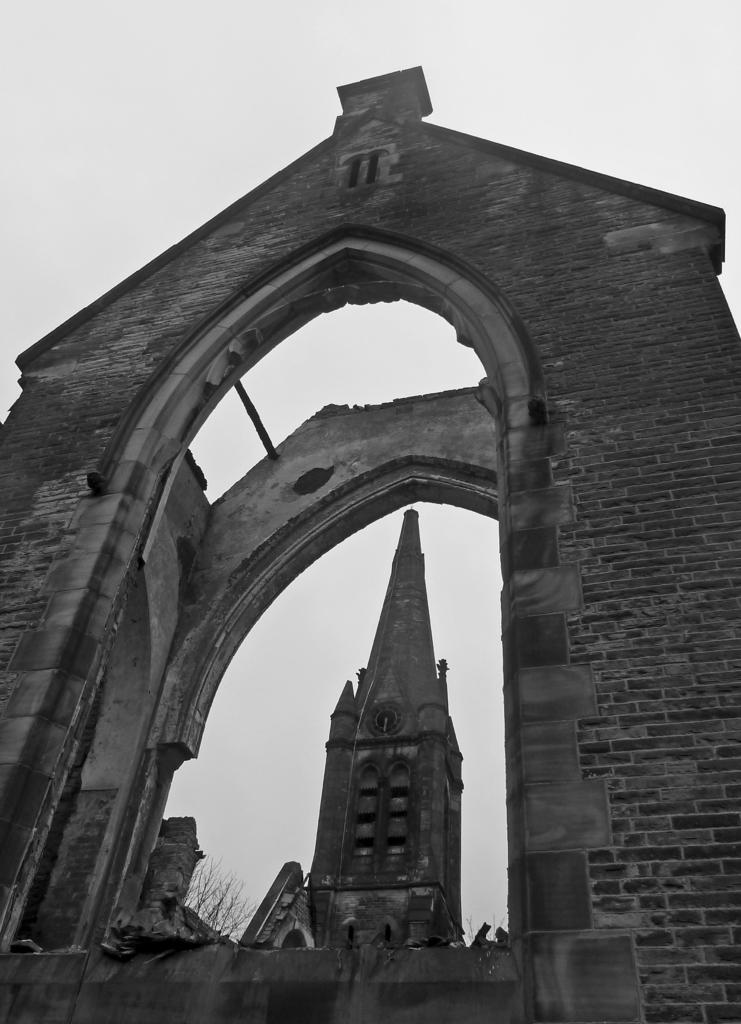Where was the picture taken? The picture was clicked outside. What can be seen in the foreground of the image? There are brick walls in the foreground, and they have an arch. What is the main subject in the center of the image? There is a spire in the center of the image. What can be seen in the background of the image? The sky is visible in the background. What type of income can be seen in the image? There is no income visible in the image; it features brick walls, a spire, and the sky. Is there a lunchroom in the alley shown in the image? There is no alley or lunchroom present in the image. 